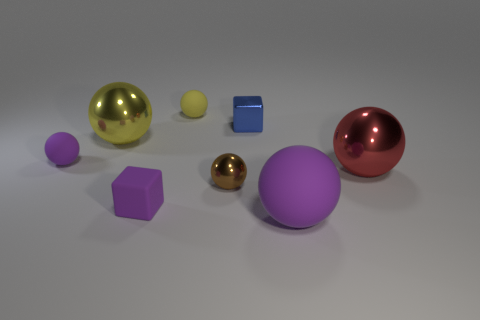How big is the cube that is in front of the purple sphere that is on the left side of the purple sphere that is on the right side of the yellow rubber ball?
Your answer should be compact. Small. What number of objects are either shiny objects that are right of the big matte ball or red metallic balls?
Give a very brief answer. 1. What number of tiny brown spheres are behind the object that is left of the yellow metallic ball?
Keep it short and to the point. 0. Is the number of blue metal things in front of the tiny blue object greater than the number of brown shiny balls?
Provide a succinct answer. No. There is a purple matte thing that is in front of the big red object and left of the tiny brown thing; what is its size?
Your answer should be compact. Small. What is the shape of the large object that is to the right of the tiny brown ball and on the left side of the large red shiny ball?
Ensure brevity in your answer.  Sphere. Are there any tiny blue metal cubes that are right of the rubber object to the right of the small matte thing behind the big yellow ball?
Your answer should be compact. No. What number of things are large things that are left of the big purple rubber sphere or big metallic things that are on the right side of the yellow metal ball?
Offer a very short reply. 2. Is the tiny block behind the red ball made of the same material as the large purple object?
Make the answer very short. No. There is a big ball that is on the left side of the large red object and behind the small brown object; what material is it made of?
Provide a short and direct response. Metal. 